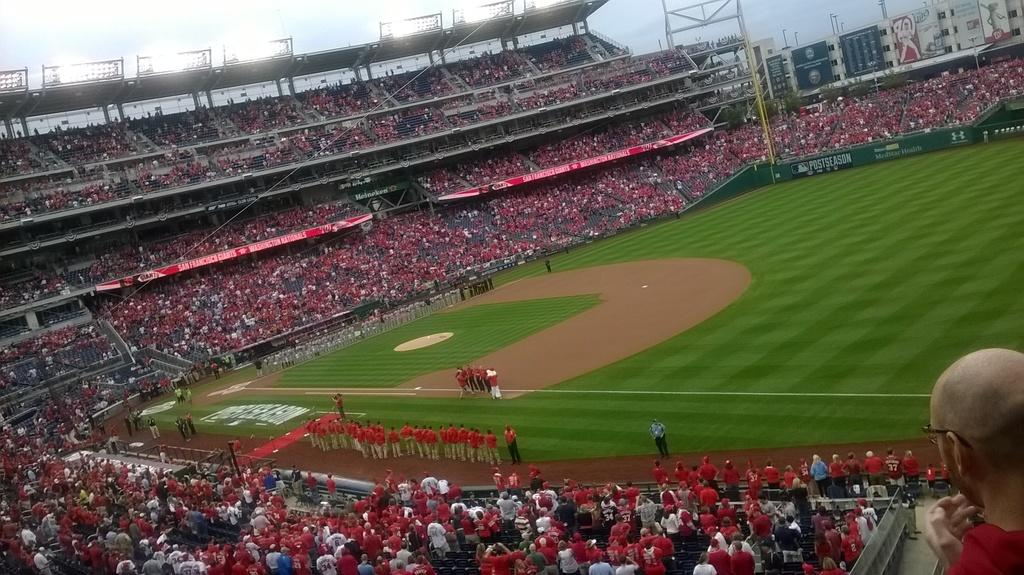What color is the ground in the image? The ground in the image is green. What are the people doing on the green ground? There are many people sitting and standing around the ground. What year is depicted in the image? The provided facts do not mention any specific year, so it cannot be determined from the image. 